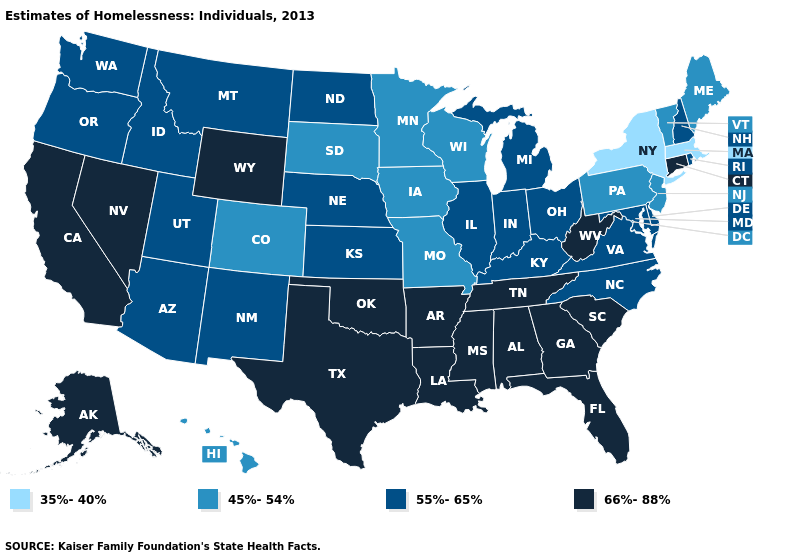Among the states that border Connecticut , which have the lowest value?
Be succinct. Massachusetts, New York. Does Nebraska have a higher value than Missouri?
Be succinct. Yes. Name the states that have a value in the range 55%-65%?
Concise answer only. Arizona, Delaware, Idaho, Illinois, Indiana, Kansas, Kentucky, Maryland, Michigan, Montana, Nebraska, New Hampshire, New Mexico, North Carolina, North Dakota, Ohio, Oregon, Rhode Island, Utah, Virginia, Washington. What is the value of Maine?
Concise answer only. 45%-54%. Which states have the lowest value in the USA?
Give a very brief answer. Massachusetts, New York. What is the value of Virginia?
Quick response, please. 55%-65%. Which states have the lowest value in the South?
Concise answer only. Delaware, Kentucky, Maryland, North Carolina, Virginia. Name the states that have a value in the range 45%-54%?
Answer briefly. Colorado, Hawaii, Iowa, Maine, Minnesota, Missouri, New Jersey, Pennsylvania, South Dakota, Vermont, Wisconsin. Does Maryland have a lower value than Oregon?
Keep it brief. No. What is the value of Tennessee?
Answer briefly. 66%-88%. Name the states that have a value in the range 45%-54%?
Be succinct. Colorado, Hawaii, Iowa, Maine, Minnesota, Missouri, New Jersey, Pennsylvania, South Dakota, Vermont, Wisconsin. Which states have the highest value in the USA?
Quick response, please. Alabama, Alaska, Arkansas, California, Connecticut, Florida, Georgia, Louisiana, Mississippi, Nevada, Oklahoma, South Carolina, Tennessee, Texas, West Virginia, Wyoming. Name the states that have a value in the range 35%-40%?
Give a very brief answer. Massachusetts, New York. Name the states that have a value in the range 66%-88%?
Keep it brief. Alabama, Alaska, Arkansas, California, Connecticut, Florida, Georgia, Louisiana, Mississippi, Nevada, Oklahoma, South Carolina, Tennessee, Texas, West Virginia, Wyoming. Does Idaho have a higher value than Oklahoma?
Give a very brief answer. No. 